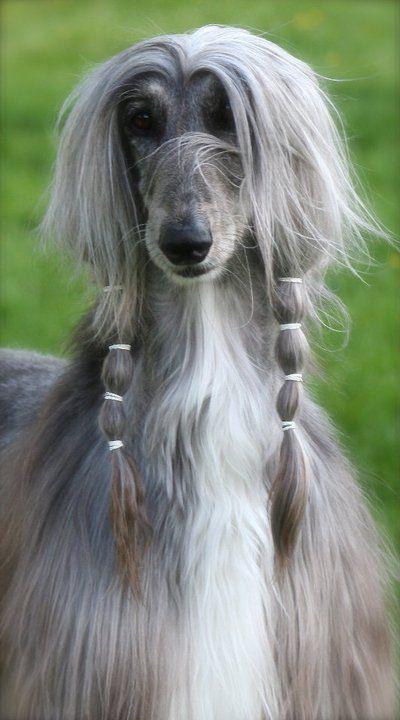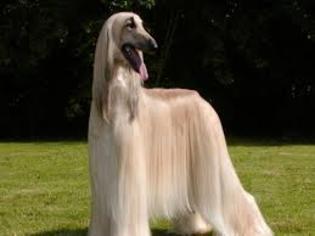The first image is the image on the left, the second image is the image on the right. For the images shown, is this caption "2 walking dogs have curled tails." true? Answer yes or no. No. The first image is the image on the left, the second image is the image on the right. For the images displayed, is the sentence "There are two dogs facing each other." factually correct? Answer yes or no. No. 